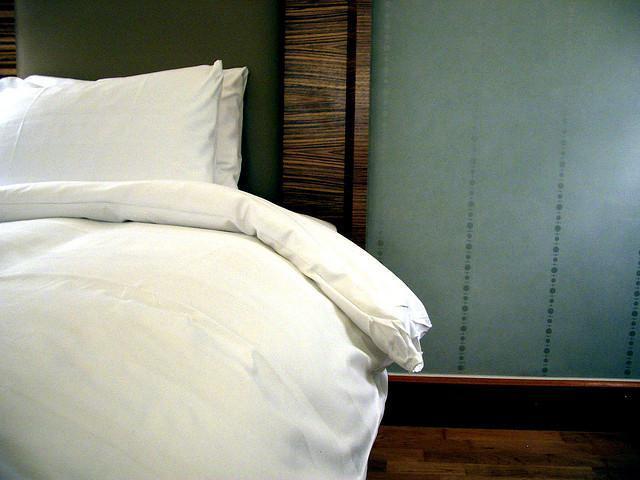How many black umbrellas are there?
Give a very brief answer. 0. 